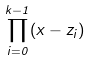Convert formula to latex. <formula><loc_0><loc_0><loc_500><loc_500>\prod _ { i = 0 } ^ { k - 1 } ( x - z _ { i } )</formula> 